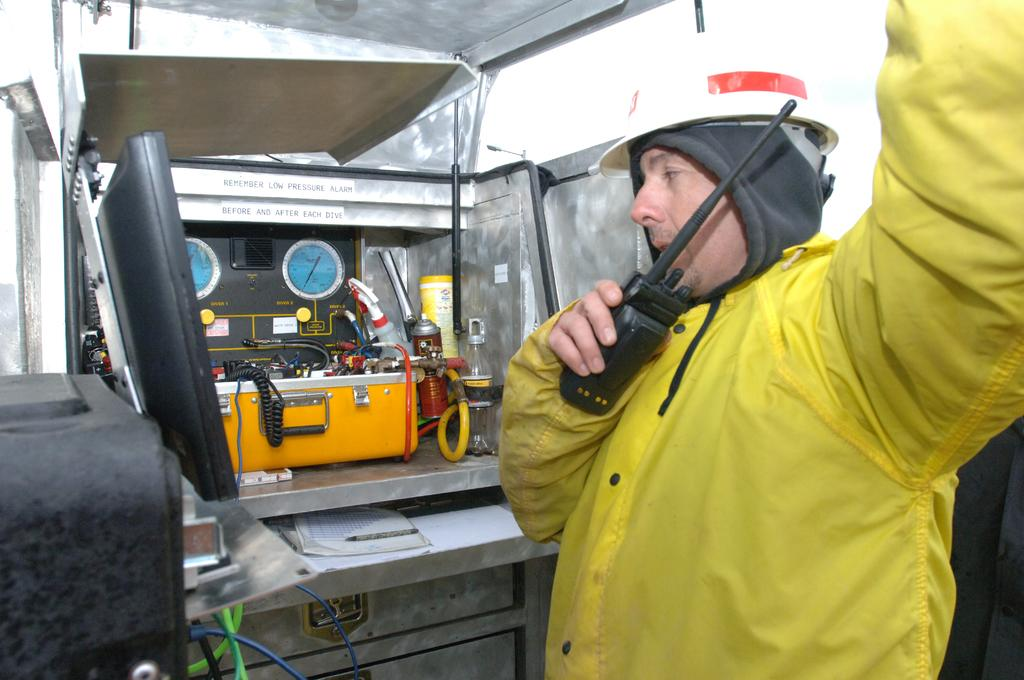What is the man in the image doing? The man is standing in the image. What is the man wearing on his head? The man is wearing a helmet. What device is the man holding in his hand? The man is holding a walkie-talkie. What can be seen in the background of the image? There is equipment in the background of the image. Can you see the ocean in the background of the image? No, there is no ocean visible in the image. How many houses are present in the image? There are no houses present in the image. 